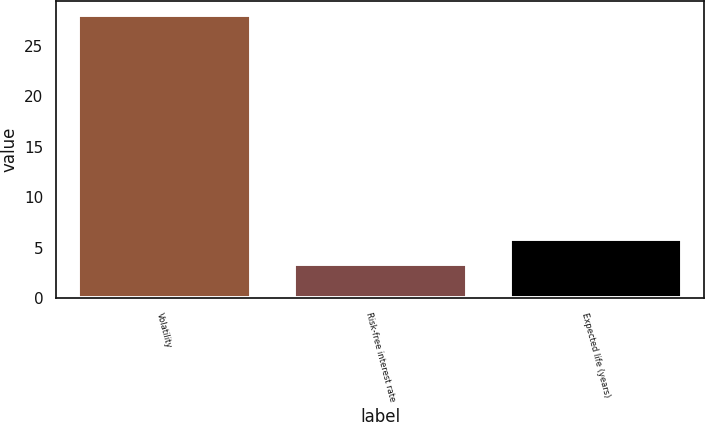Convert chart. <chart><loc_0><loc_0><loc_500><loc_500><bar_chart><fcel>Volatility<fcel>Risk-free interest rate<fcel>Expected life (years)<nl><fcel>28<fcel>3.4<fcel>5.86<nl></chart> 